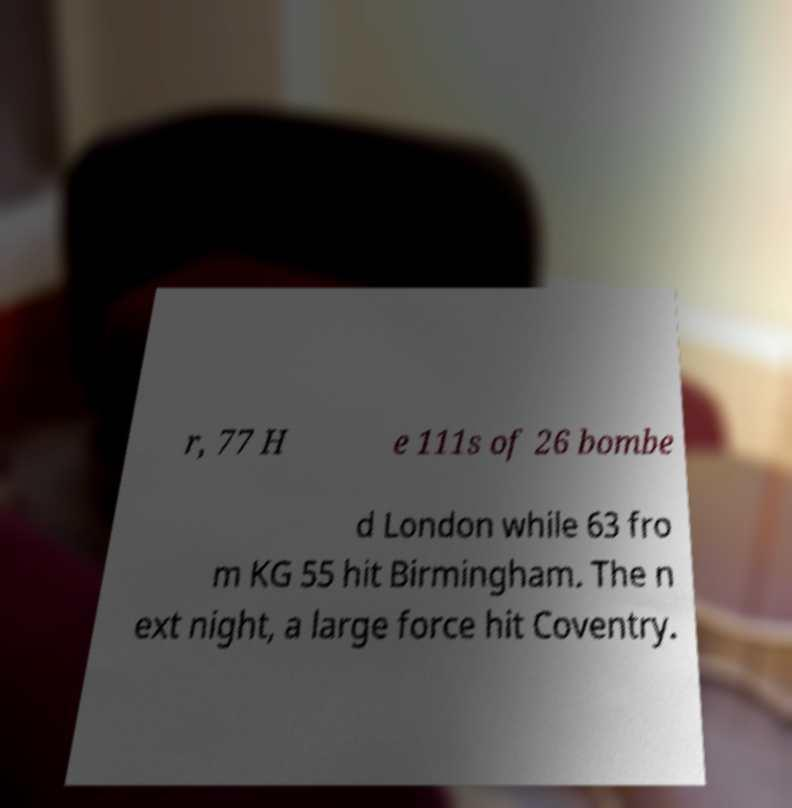Please identify and transcribe the text found in this image. r, 77 H e 111s of 26 bombe d London while 63 fro m KG 55 hit Birmingham. The n ext night, a large force hit Coventry. 